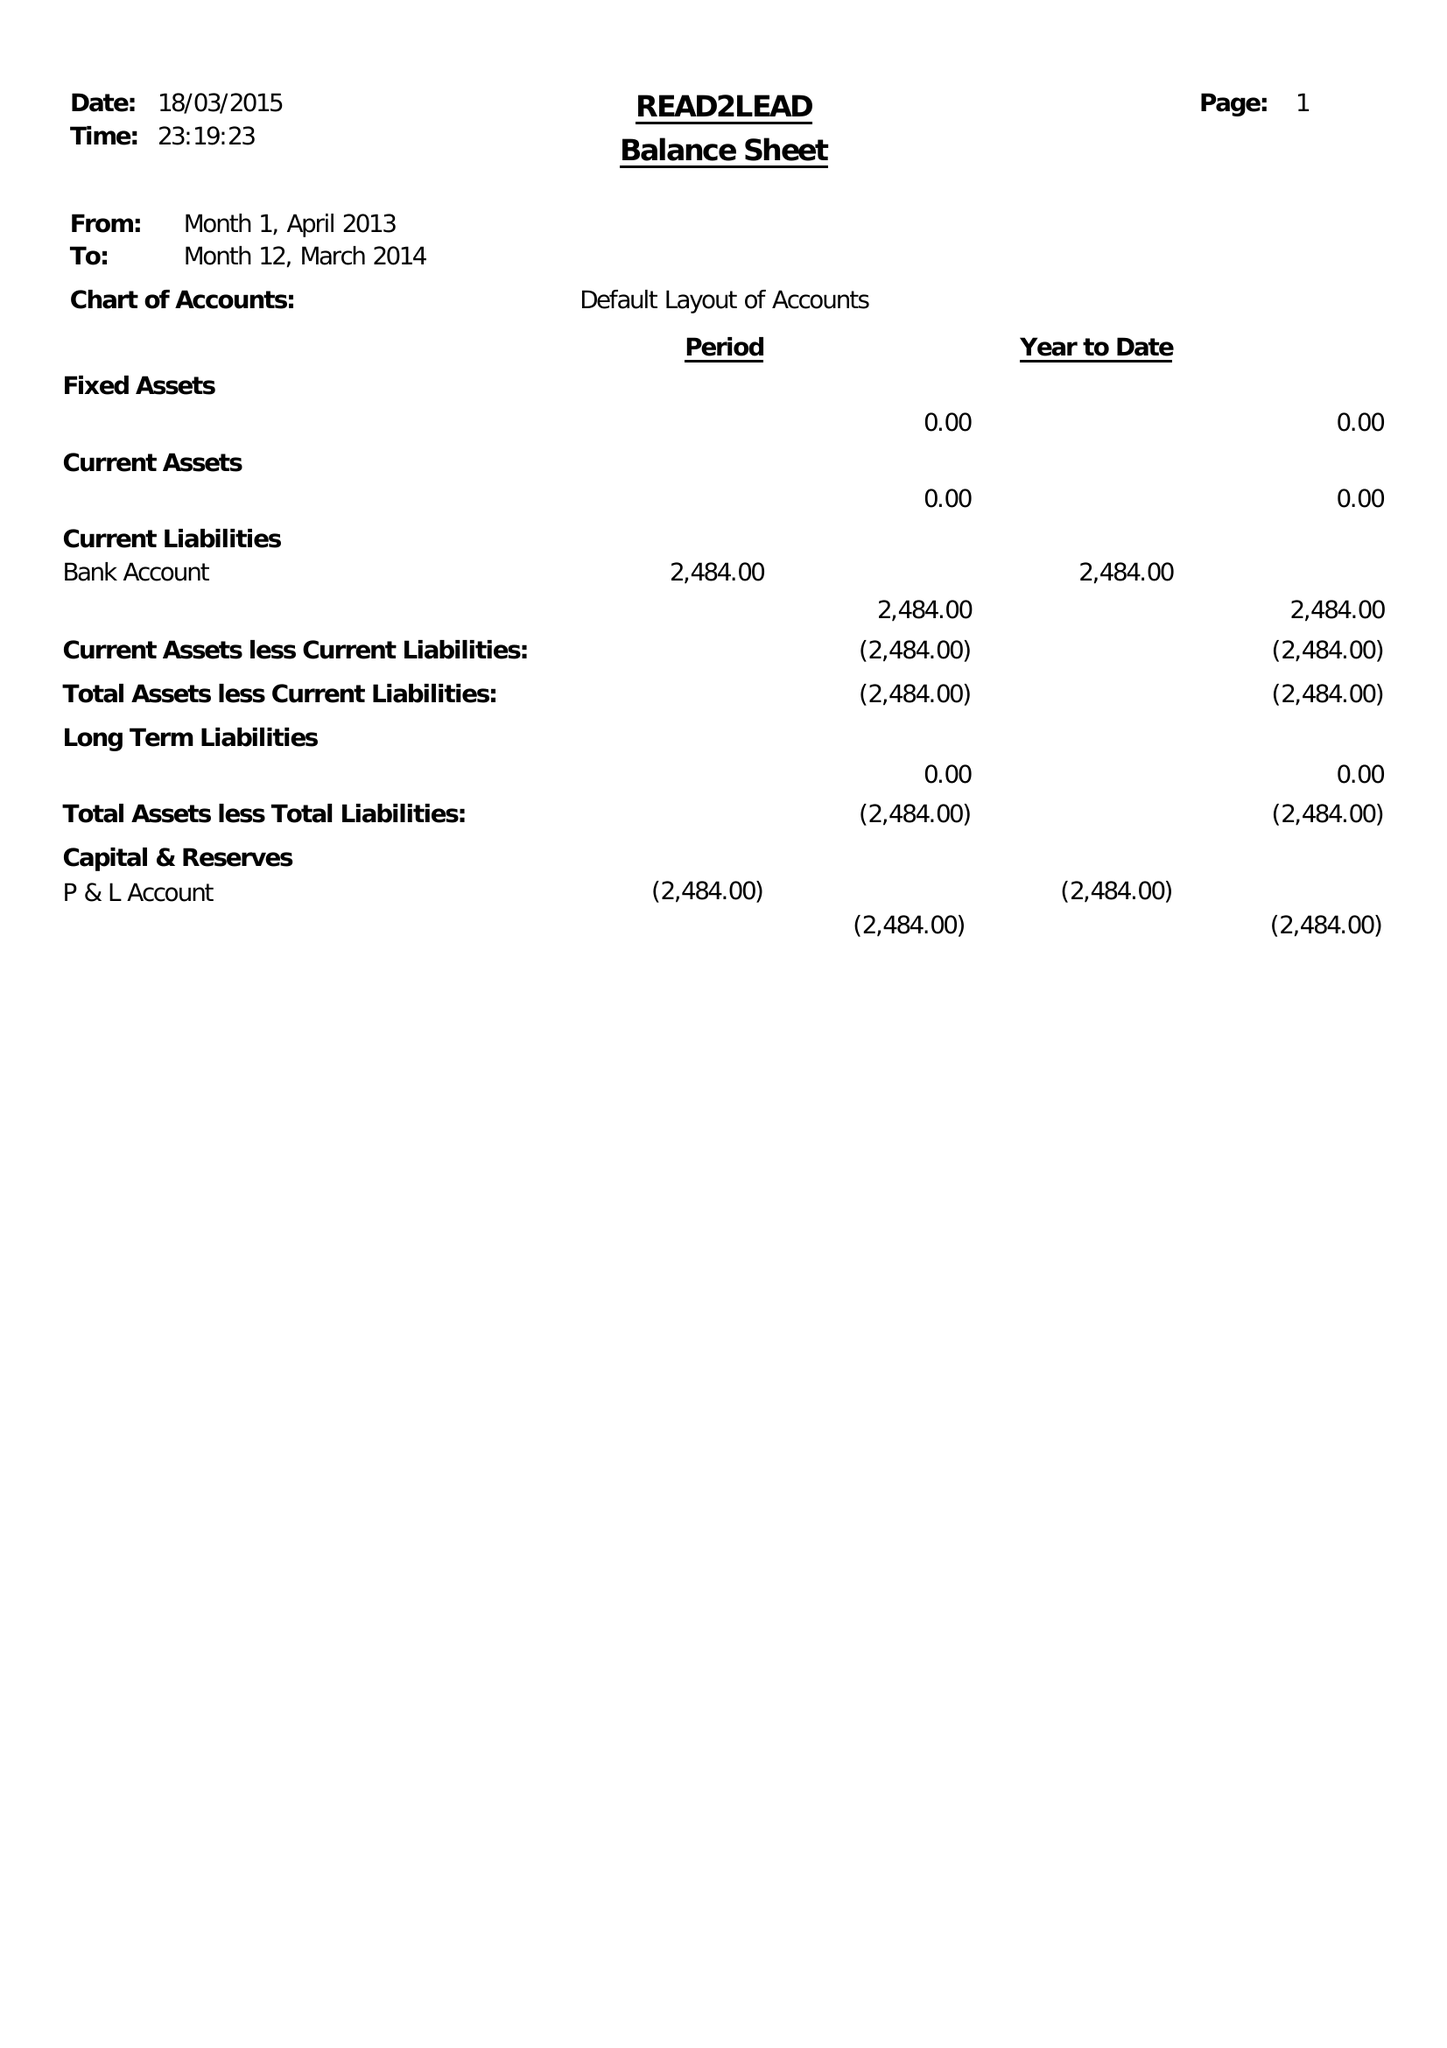What is the value for the charity_name?
Answer the question using a single word or phrase. Read2lead 